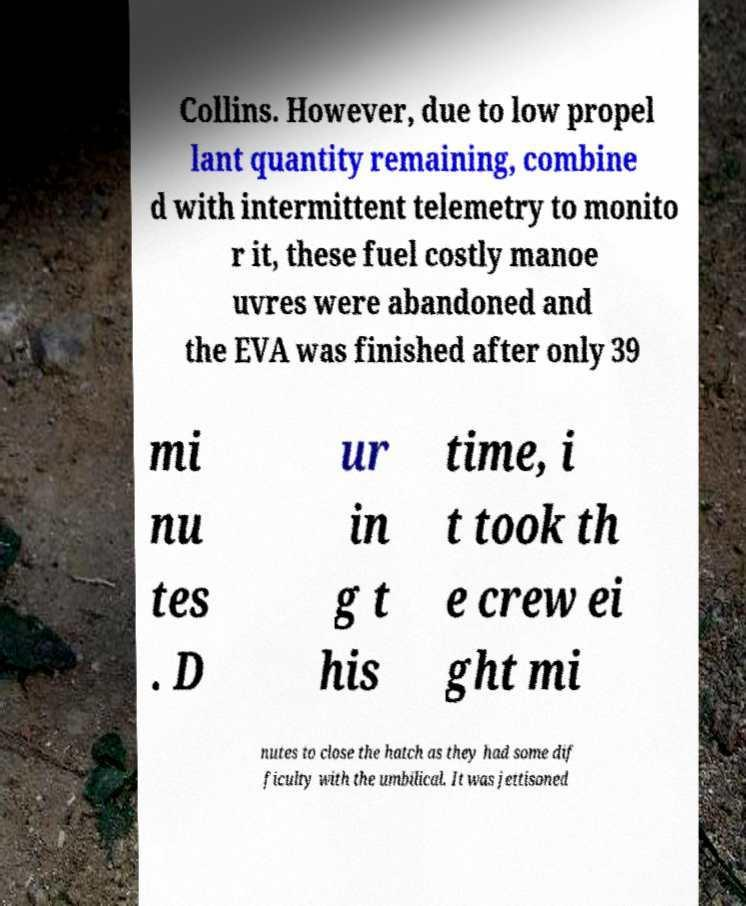Please read and relay the text visible in this image. What does it say? Collins. However, due to low propel lant quantity remaining, combine d with intermittent telemetry to monito r it, these fuel costly manoe uvres were abandoned and the EVA was finished after only 39 mi nu tes . D ur in g t his time, i t took th e crew ei ght mi nutes to close the hatch as they had some dif ficulty with the umbilical. It was jettisoned 